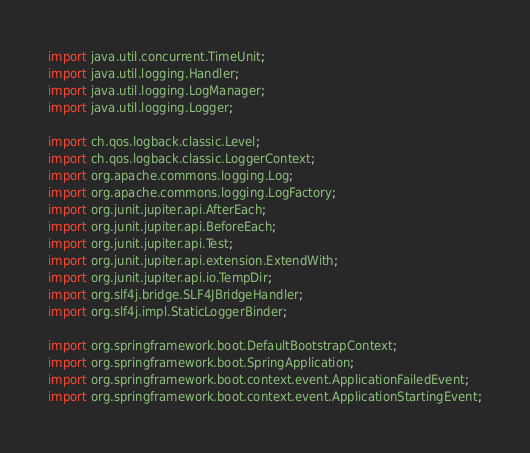Convert code to text. <code><loc_0><loc_0><loc_500><loc_500><_Java_>import java.util.concurrent.TimeUnit;
import java.util.logging.Handler;
import java.util.logging.LogManager;
import java.util.logging.Logger;

import ch.qos.logback.classic.Level;
import ch.qos.logback.classic.LoggerContext;
import org.apache.commons.logging.Log;
import org.apache.commons.logging.LogFactory;
import org.junit.jupiter.api.AfterEach;
import org.junit.jupiter.api.BeforeEach;
import org.junit.jupiter.api.Test;
import org.junit.jupiter.api.extension.ExtendWith;
import org.junit.jupiter.api.io.TempDir;
import org.slf4j.bridge.SLF4JBridgeHandler;
import org.slf4j.impl.StaticLoggerBinder;

import org.springframework.boot.DefaultBootstrapContext;
import org.springframework.boot.SpringApplication;
import org.springframework.boot.context.event.ApplicationFailedEvent;
import org.springframework.boot.context.event.ApplicationStartingEvent;</code> 